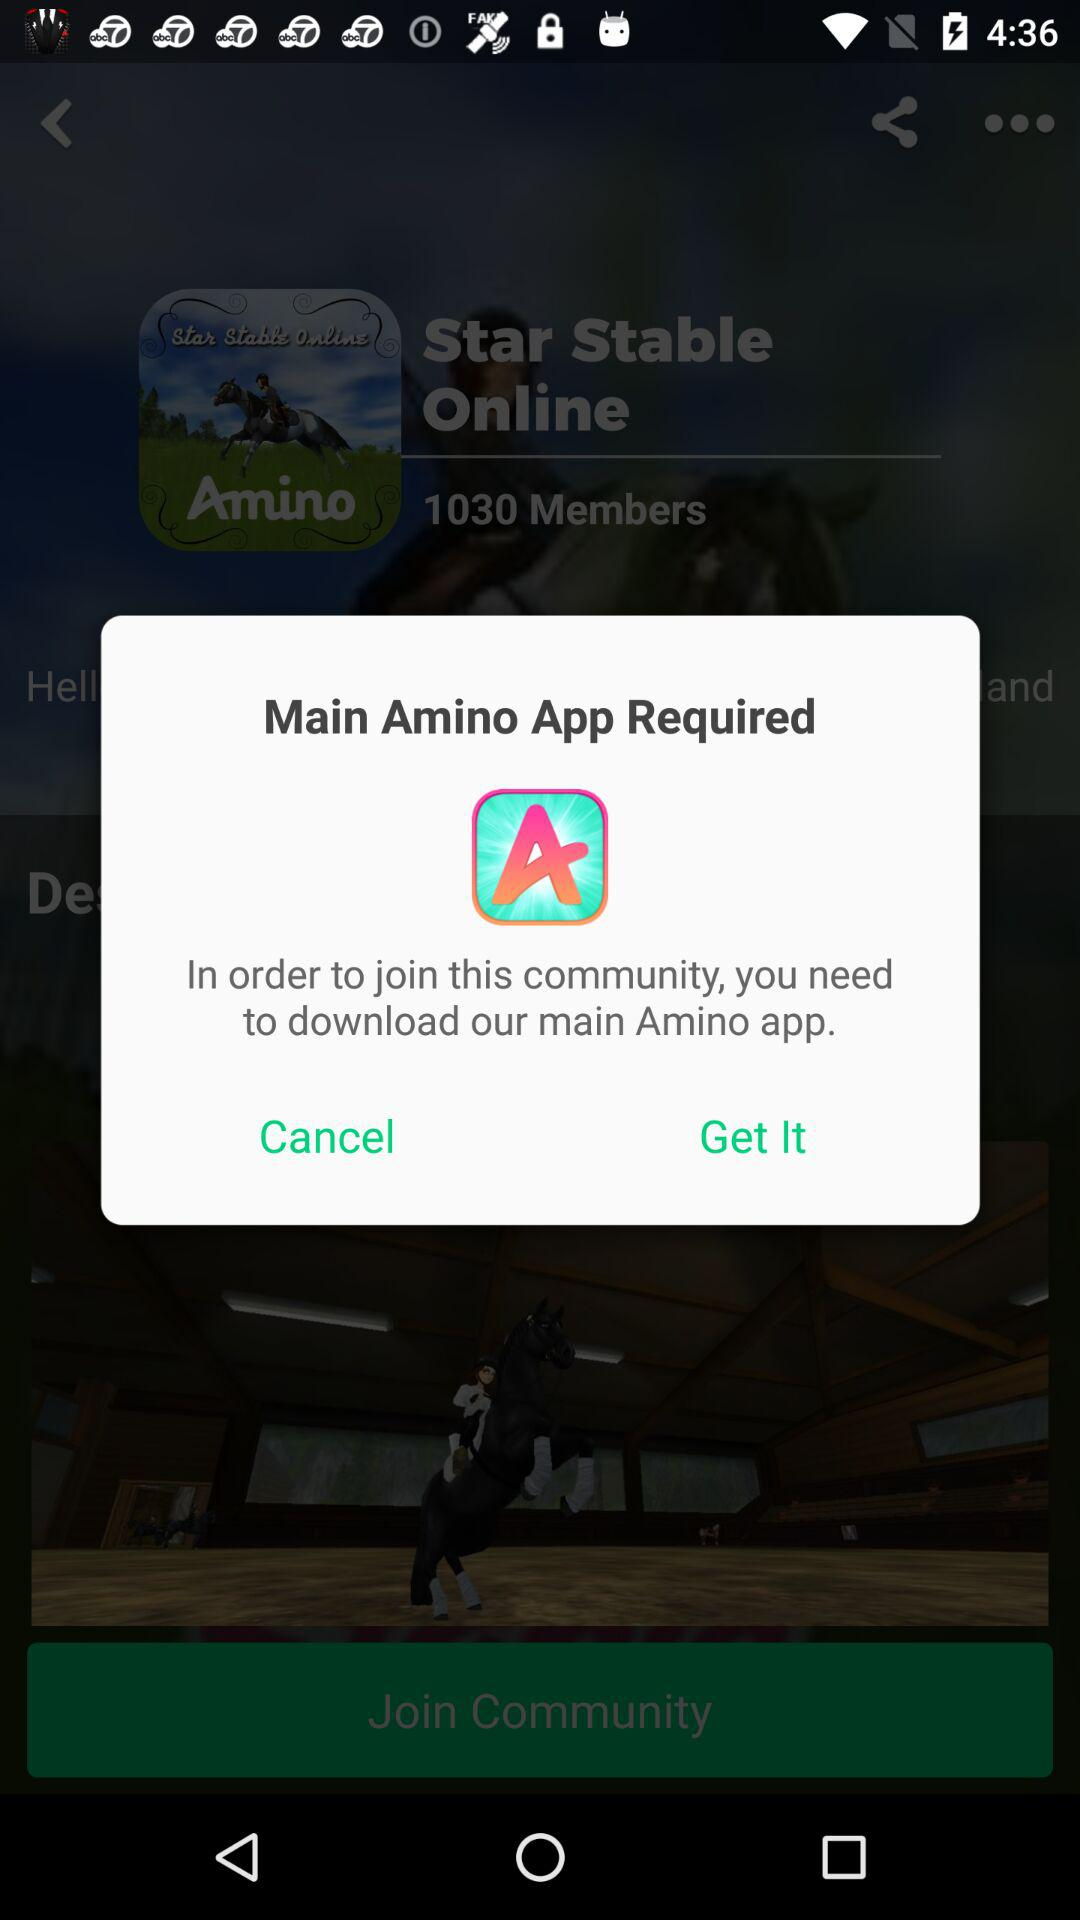What is the number of members? The number of members is 1030. 